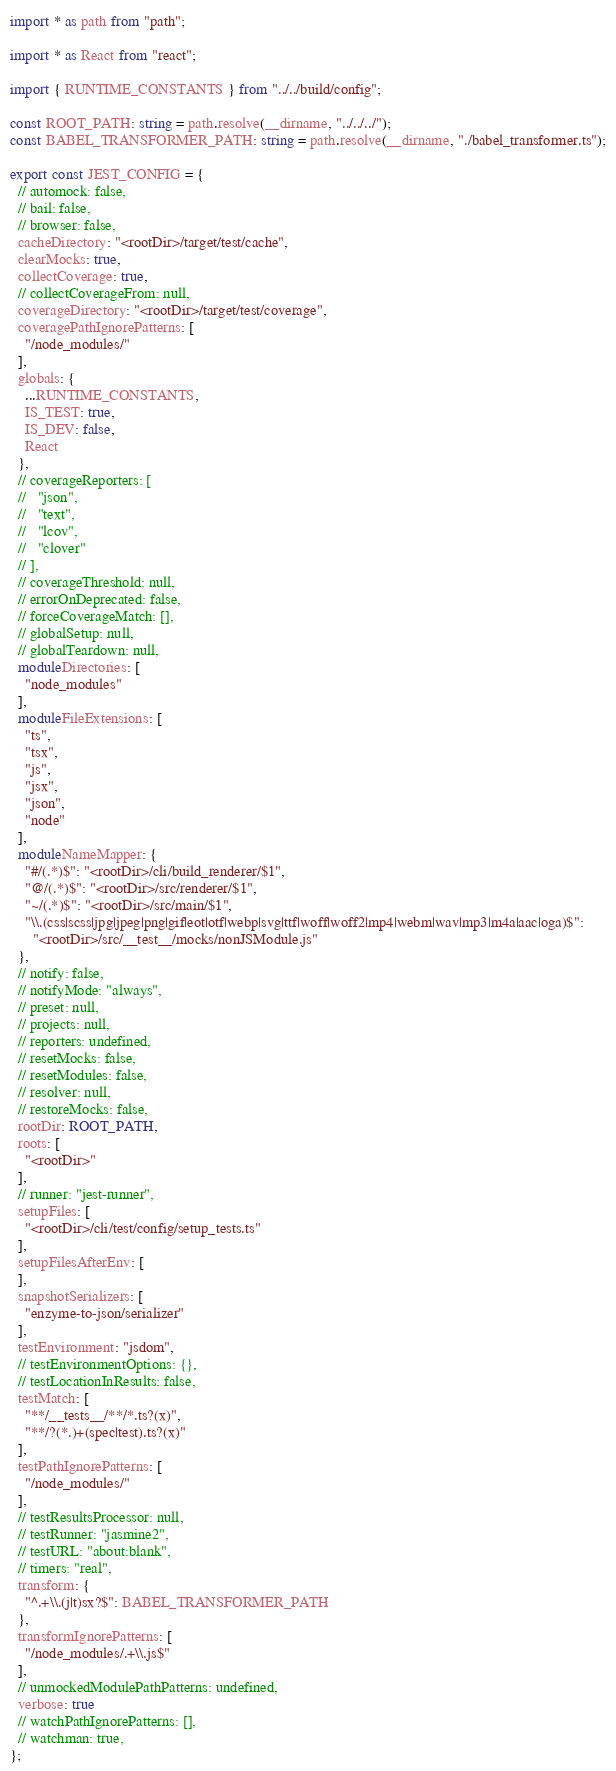Convert code to text. <code><loc_0><loc_0><loc_500><loc_500><_TypeScript_>import * as path from "path";

import * as React from "react";

import { RUNTIME_CONSTANTS } from "../../build/config";

const ROOT_PATH: string = path.resolve(__dirname, "../../../");
const BABEL_TRANSFORMER_PATH: string = path.resolve(__dirname, "./babel_transformer.ts");

export const JEST_CONFIG = {
  // automock: false,
  // bail: false,
  // browser: false,
  cacheDirectory: "<rootDir>/target/test/cache",
  clearMocks: true,
  collectCoverage: true,
  // collectCoverageFrom: null,
  coverageDirectory: "<rootDir>/target/test/coverage",
  coveragePathIgnorePatterns: [
    "/node_modules/"
  ],
  globals: {
    ...RUNTIME_CONSTANTS,
    IS_TEST: true,
    IS_DEV: false,
    React
  },
  // coverageReporters: [
  //   "json",
  //   "text",
  //   "lcov",
  //   "clover"
  // ],
  // coverageThreshold: null,
  // errorOnDeprecated: false,
  // forceCoverageMatch: [],
  // globalSetup: null,
  // globalTeardown: null,
  moduleDirectories: [
    "node_modules"
  ],
  moduleFileExtensions: [
    "ts",
    "tsx",
    "js",
    "jsx",
    "json",
    "node"
  ],
  moduleNameMapper: {
    "#/(.*)$": "<rootDir>/cli/build_renderer/$1",
    "@/(.*)$": "<rootDir>/src/renderer/$1",
    "~/(.*)$": "<rootDir>/src/main/$1",
    "\\.(css|scss|jpg|jpeg|png|gif|eot|otf|webp|svg|ttf|woff|woff2|mp4|webm|wav|mp3|m4a|aac|oga)$":
      "<rootDir>/src/__test__/mocks/nonJSModule.js"
  },
  // notify: false,
  // notifyMode: "always",
  // preset: null,
  // projects: null,
  // reporters: undefined,
  // resetMocks: false,
  // resetModules: false,
  // resolver: null,
  // restoreMocks: false,
  rootDir: ROOT_PATH,
  roots: [
    "<rootDir>"
  ],
  // runner: "jest-runner",
  setupFiles: [
    "<rootDir>/cli/test/config/setup_tests.ts"
  ],
  setupFilesAfterEnv: [
  ],
  snapshotSerializers: [
    "enzyme-to-json/serializer"
  ],
  testEnvironment: "jsdom",
  // testEnvironmentOptions: {},
  // testLocationInResults: false,
  testMatch: [
    "**/__tests__/**/*.ts?(x)",
    "**/?(*.)+(spec|test).ts?(x)"
  ],
  testPathIgnorePatterns: [
    "/node_modules/"
  ],
  // testResultsProcessor: null,
  // testRunner: "jasmine2",
  // testURL: "about:blank",
  // timers: "real",
  transform: {
    "^.+\\.(j|t)sx?$": BABEL_TRANSFORMER_PATH
  },
  transformIgnorePatterns: [
    "/node_modules/.+\\.js$"
  ],
  // unmockedModulePathPatterns: undefined,
  verbose: true
  // watchPathIgnorePatterns: [],
  // watchman: true,
};
</code> 